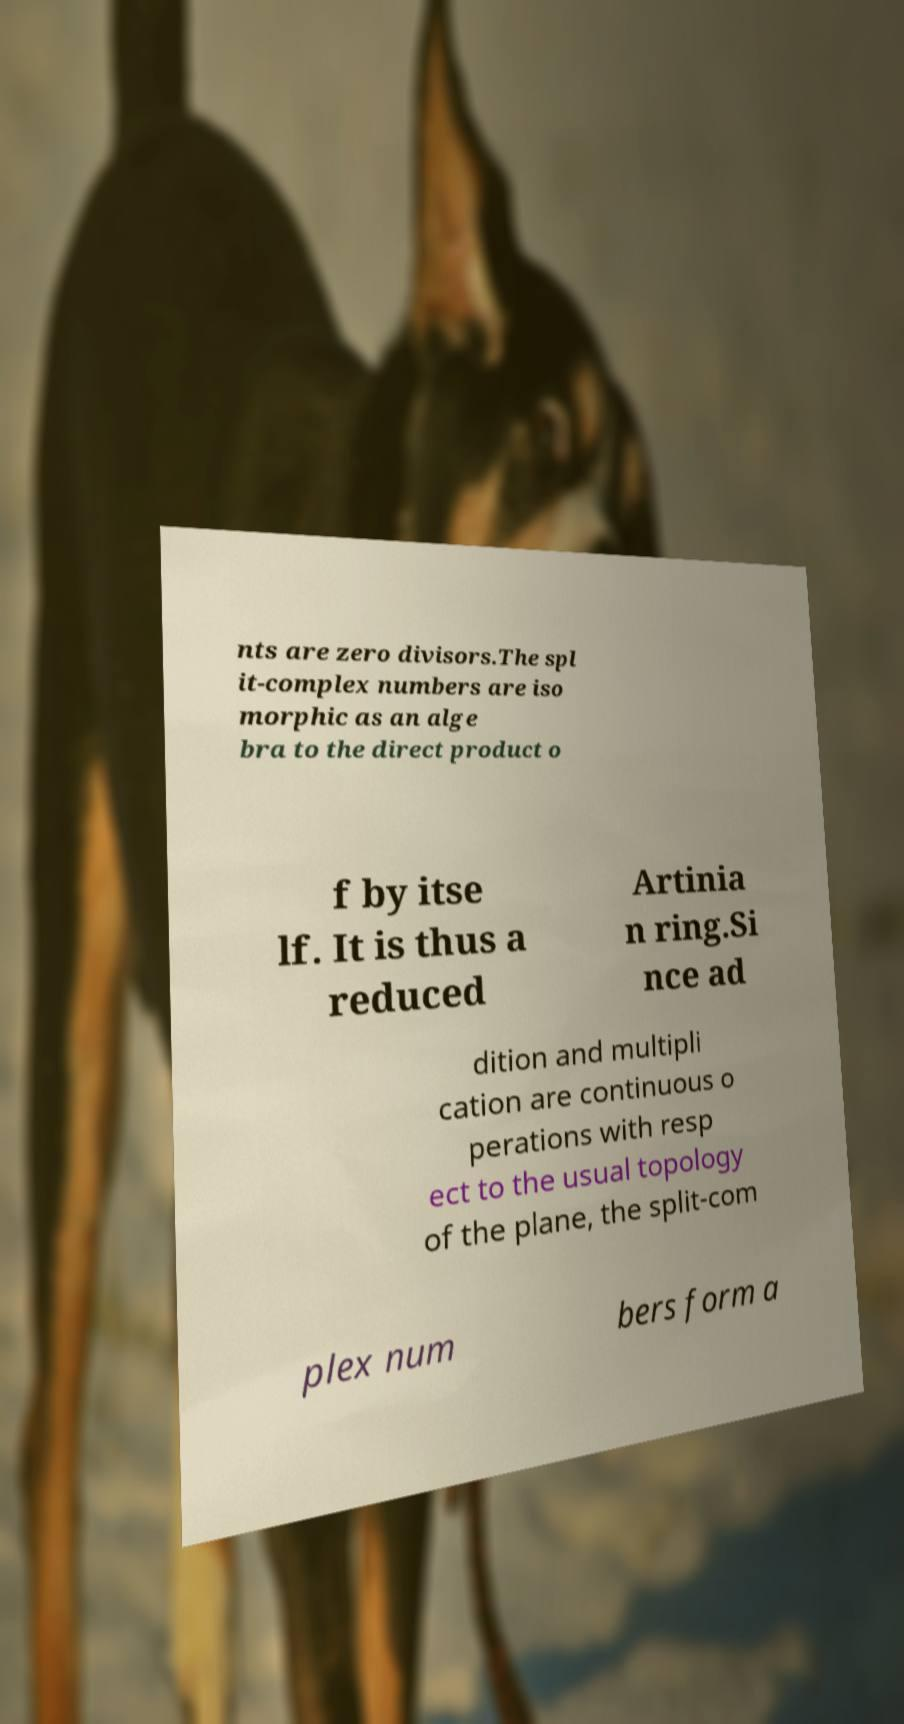Please read and relay the text visible in this image. What does it say? nts are zero divisors.The spl it-complex numbers are iso morphic as an alge bra to the direct product o f by itse lf. It is thus a reduced Artinia n ring.Si nce ad dition and multipli cation are continuous o perations with resp ect to the usual topology of the plane, the split-com plex num bers form a 